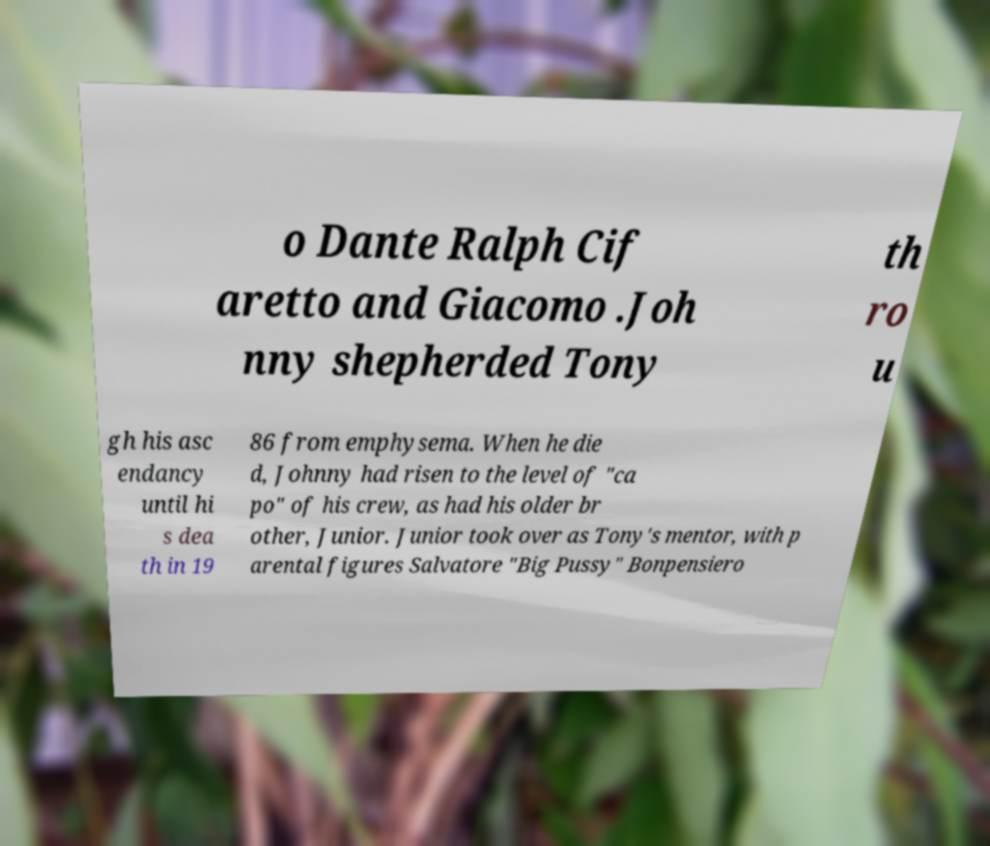Can you read and provide the text displayed in the image?This photo seems to have some interesting text. Can you extract and type it out for me? o Dante Ralph Cif aretto and Giacomo .Joh nny shepherded Tony th ro u gh his asc endancy until hi s dea th in 19 86 from emphysema. When he die d, Johnny had risen to the level of "ca po" of his crew, as had his older br other, Junior. Junior took over as Tony's mentor, with p arental figures Salvatore "Big Pussy" Bonpensiero 